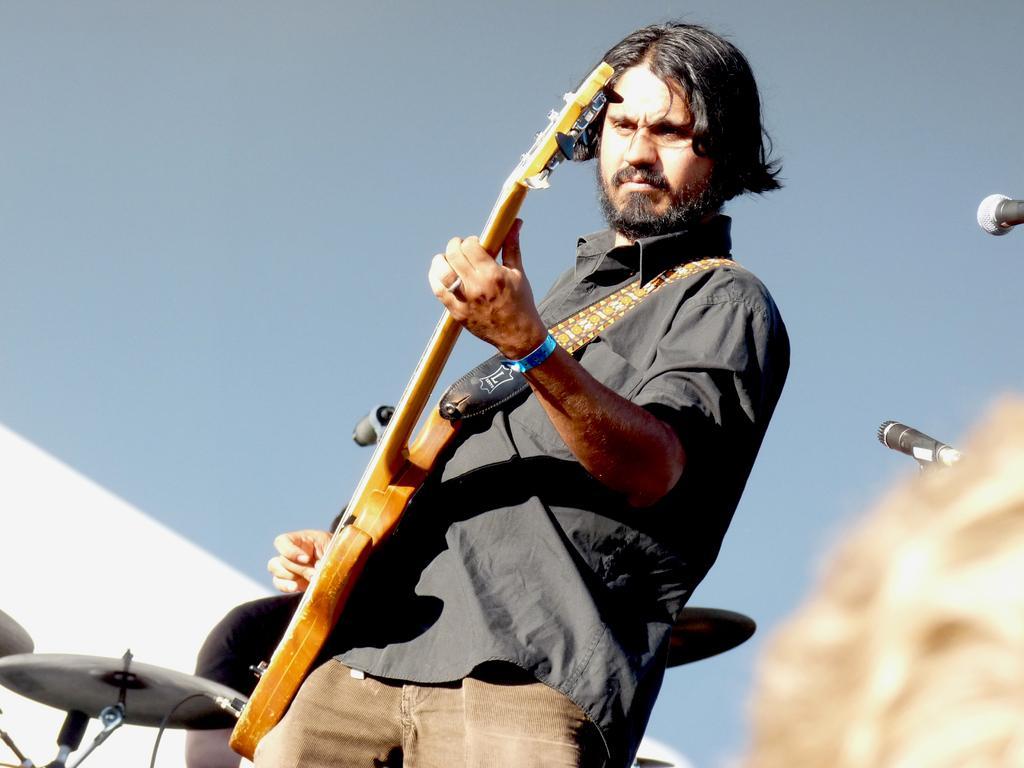In one or two sentences, can you explain what this image depicts? In this image we can see few persons. A person is playing a musical instrument in the image. There are few musical instruments in the image. There are two mics at the rights of the image. 